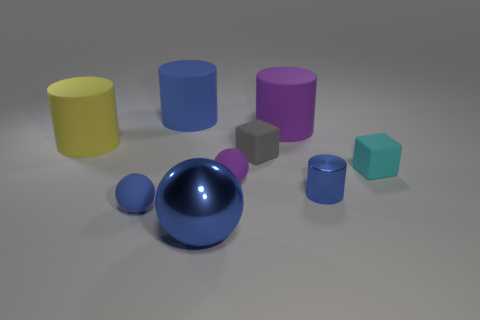What number of spheres are there?
Make the answer very short. 3. There is a large purple thing that is right of the large metallic sphere; is its shape the same as the gray object?
Make the answer very short. No. What material is the cyan cube that is the same size as the purple ball?
Offer a terse response. Rubber. Is there a big red sphere that has the same material as the tiny gray object?
Ensure brevity in your answer.  No. Is the shape of the big yellow thing the same as the small blue object that is behind the tiny blue rubber ball?
Provide a succinct answer. Yes. What number of big blue objects are behind the big yellow object and in front of the small gray object?
Your answer should be compact. 0. Is the material of the small blue sphere the same as the blue cylinder to the right of the large blue cylinder?
Keep it short and to the point. No. Are there an equal number of big cylinders in front of the large yellow rubber object and small metallic objects?
Give a very brief answer. No. What color is the cylinder in front of the cyan block?
Give a very brief answer. Blue. What number of other objects are there of the same color as the tiny metal cylinder?
Your answer should be very brief. 3. 